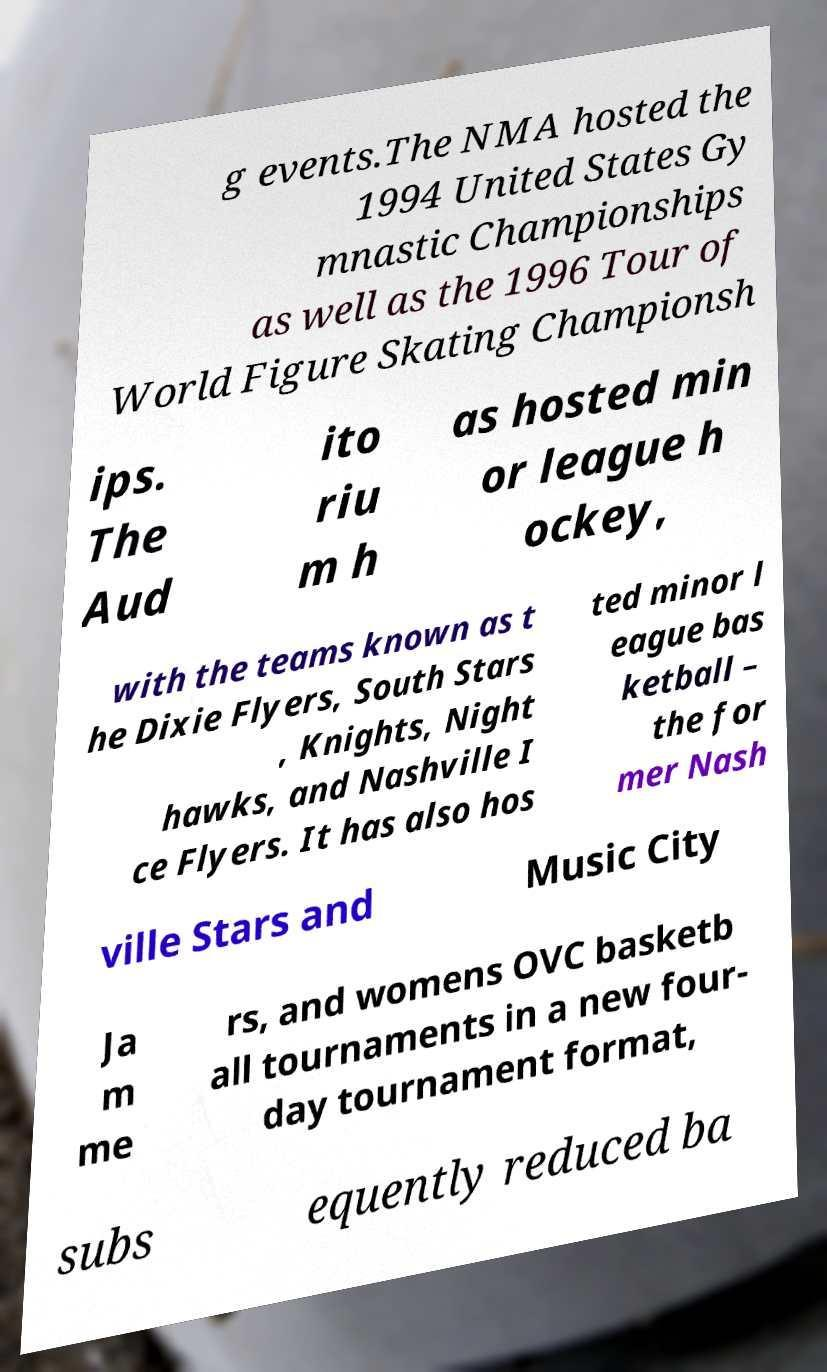Can you read and provide the text displayed in the image?This photo seems to have some interesting text. Can you extract and type it out for me? g events.The NMA hosted the 1994 United States Gy mnastic Championships as well as the 1996 Tour of World Figure Skating Championsh ips. The Aud ito riu m h as hosted min or league h ockey, with the teams known as t he Dixie Flyers, South Stars , Knights, Night hawks, and Nashville I ce Flyers. It has also hos ted minor l eague bas ketball – the for mer Nash ville Stars and Music City Ja m me rs, and womens OVC basketb all tournaments in a new four- day tournament format, subs equently reduced ba 